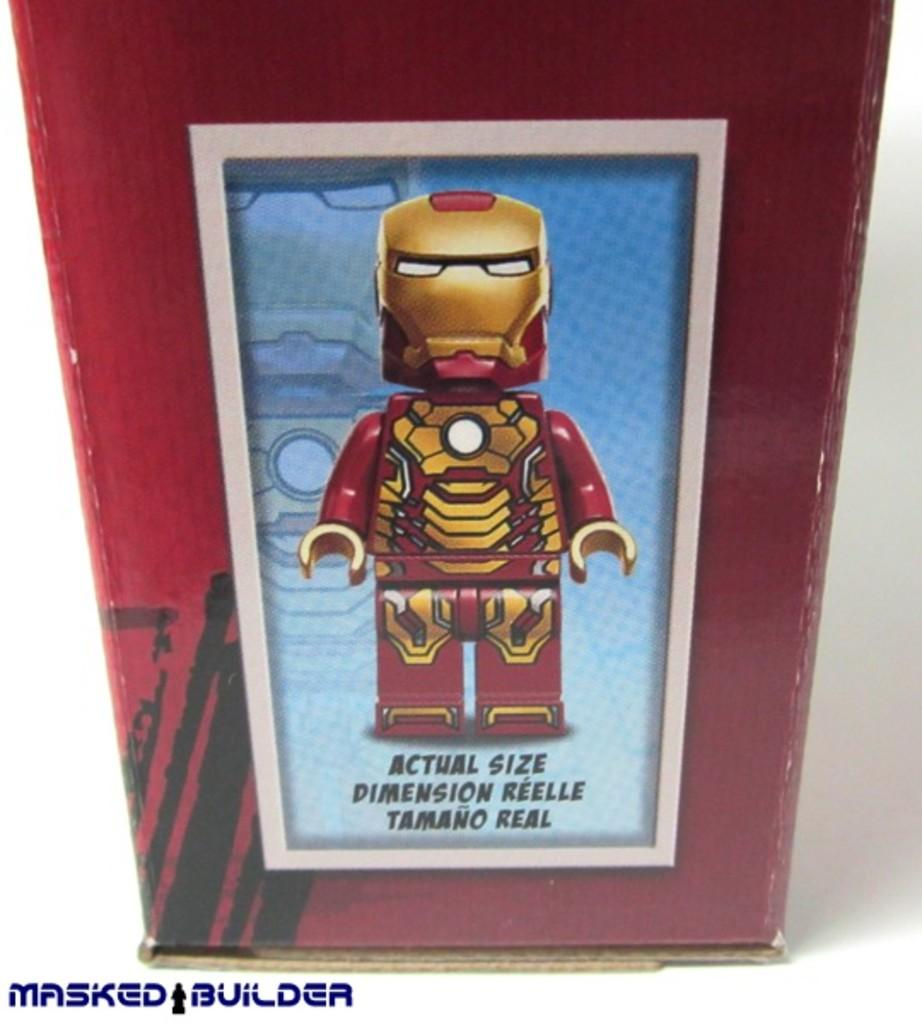<image>
Create a compact narrative representing the image presented. A picture of a toy with Actual Size written in three languages. 